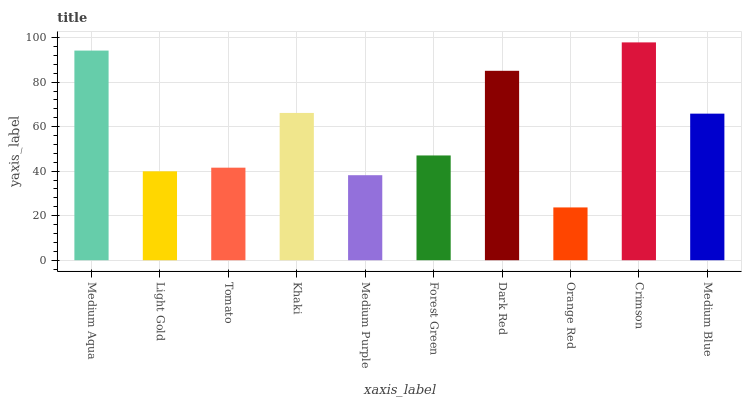Is Orange Red the minimum?
Answer yes or no. Yes. Is Crimson the maximum?
Answer yes or no. Yes. Is Light Gold the minimum?
Answer yes or no. No. Is Light Gold the maximum?
Answer yes or no. No. Is Medium Aqua greater than Light Gold?
Answer yes or no. Yes. Is Light Gold less than Medium Aqua?
Answer yes or no. Yes. Is Light Gold greater than Medium Aqua?
Answer yes or no. No. Is Medium Aqua less than Light Gold?
Answer yes or no. No. Is Medium Blue the high median?
Answer yes or no. Yes. Is Forest Green the low median?
Answer yes or no. Yes. Is Medium Purple the high median?
Answer yes or no. No. Is Medium Aqua the low median?
Answer yes or no. No. 